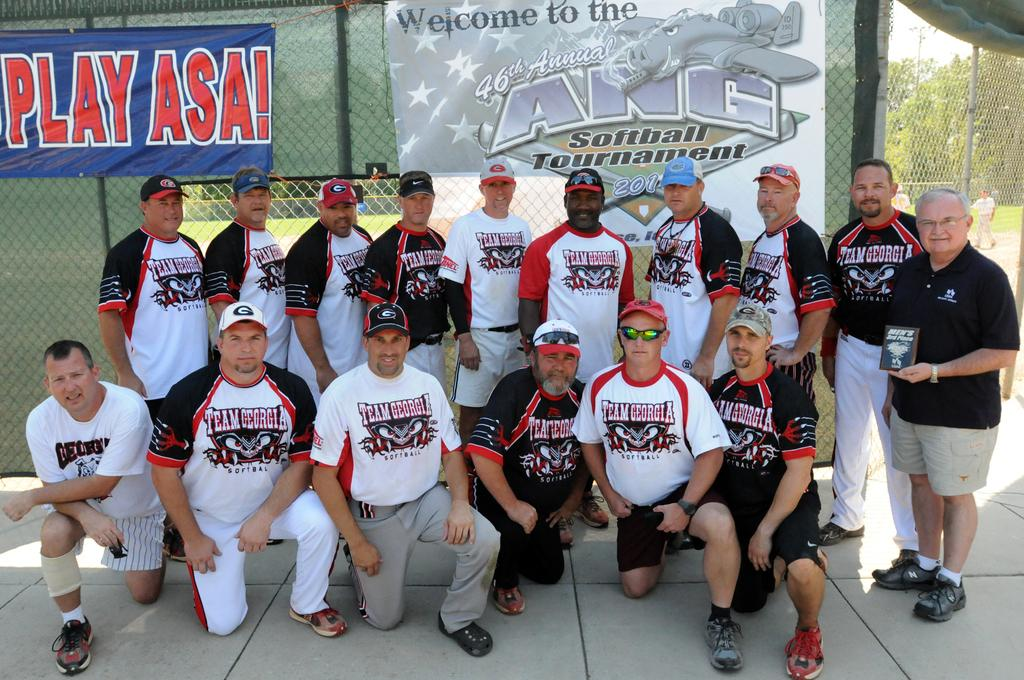<image>
Create a compact narrative representing the image presented. Men's baseball team kneeling in front of a welcome to the ANG softball tournament. 